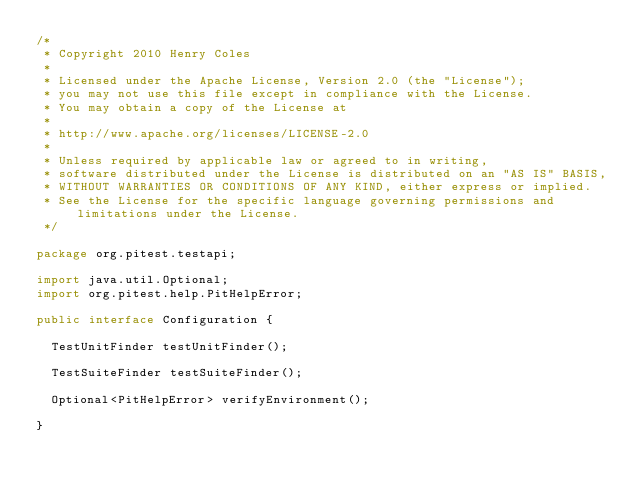Convert code to text. <code><loc_0><loc_0><loc_500><loc_500><_Java_>/*
 * Copyright 2010 Henry Coles
 *
 * Licensed under the Apache License, Version 2.0 (the "License");
 * you may not use this file except in compliance with the License.
 * You may obtain a copy of the License at
 *
 * http://www.apache.org/licenses/LICENSE-2.0
 *
 * Unless required by applicable law or agreed to in writing,
 * software distributed under the License is distributed on an "AS IS" BASIS,
 * WITHOUT WARRANTIES OR CONDITIONS OF ANY KIND, either express or implied.
 * See the License for the specific language governing permissions and limitations under the License.
 */

package org.pitest.testapi;

import java.util.Optional;
import org.pitest.help.PitHelpError;

public interface Configuration {

  TestUnitFinder testUnitFinder();

  TestSuiteFinder testSuiteFinder();

  Optional<PitHelpError> verifyEnvironment();

}
</code> 